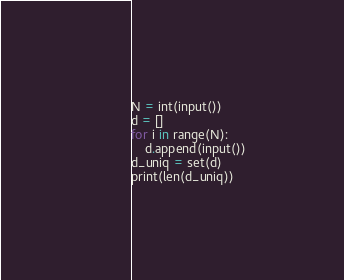<code> <loc_0><loc_0><loc_500><loc_500><_Python_>N = int(input())
d = []
for i in range(N):
    d.append(input())
d_uniq = set(d)
print(len(d_uniq))
</code> 